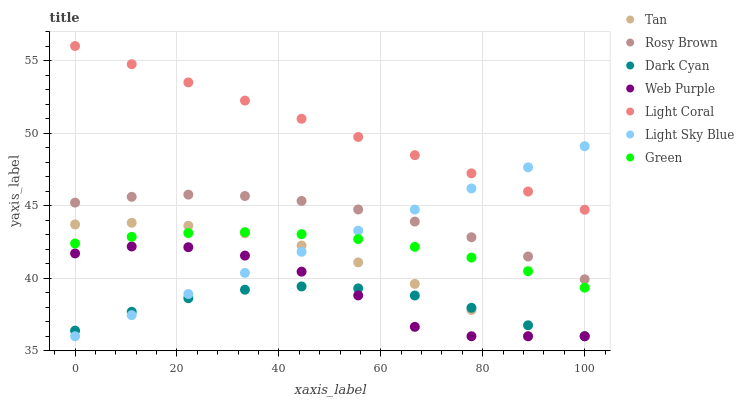Does Dark Cyan have the minimum area under the curve?
Answer yes or no. Yes. Does Light Coral have the maximum area under the curve?
Answer yes or no. Yes. Does Web Purple have the minimum area under the curve?
Answer yes or no. No. Does Web Purple have the maximum area under the curve?
Answer yes or no. No. Is Light Sky Blue the smoothest?
Answer yes or no. Yes. Is Web Purple the roughest?
Answer yes or no. Yes. Is Light Coral the smoothest?
Answer yes or no. No. Is Light Coral the roughest?
Answer yes or no. No. Does Web Purple have the lowest value?
Answer yes or no. Yes. Does Light Coral have the lowest value?
Answer yes or no. No. Does Light Coral have the highest value?
Answer yes or no. Yes. Does Web Purple have the highest value?
Answer yes or no. No. Is Rosy Brown less than Light Coral?
Answer yes or no. Yes. Is Green greater than Dark Cyan?
Answer yes or no. Yes. Does Light Coral intersect Light Sky Blue?
Answer yes or no. Yes. Is Light Coral less than Light Sky Blue?
Answer yes or no. No. Is Light Coral greater than Light Sky Blue?
Answer yes or no. No. Does Rosy Brown intersect Light Coral?
Answer yes or no. No. 